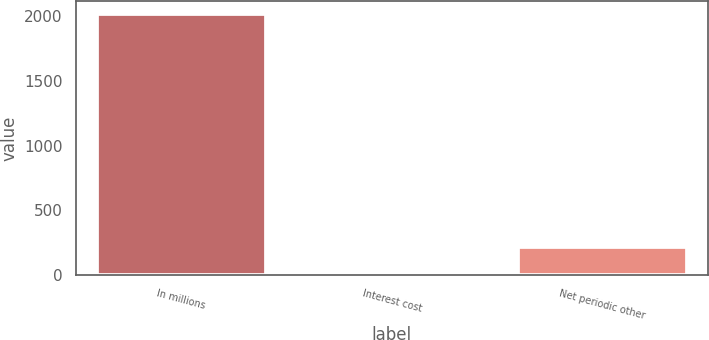<chart> <loc_0><loc_0><loc_500><loc_500><bar_chart><fcel>In millions<fcel>Interest cost<fcel>Net periodic other<nl><fcel>2016<fcel>16<fcel>216<nl></chart> 